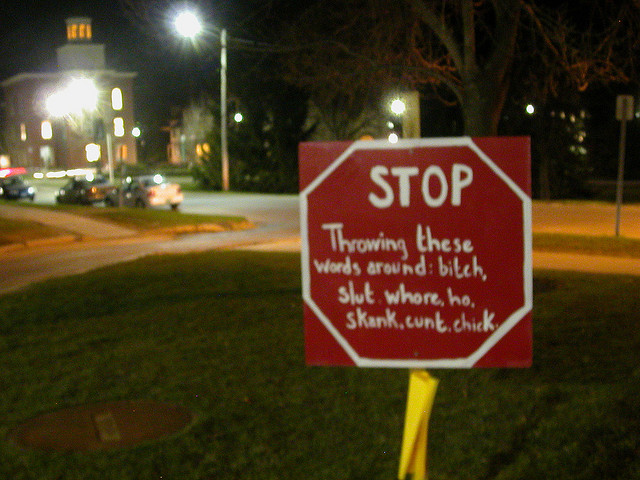Read and extract the text from this image. STOP Throwing whore these cunt chick skank ho slut bitch around words 